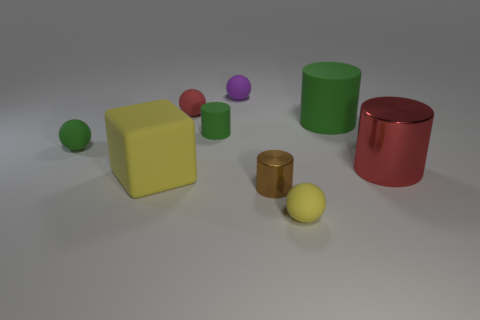How would you describe the arrangement of shapes in this image? The image presents a collection of geometric shapes arranged on a surface that resembles a standard lighting test scene. You can see a variety of shapes including spheres, cylinders, and cubes, each with different colors and sizes, positioned haphazardly, giving the impression of a diverse but unorganized composition. 